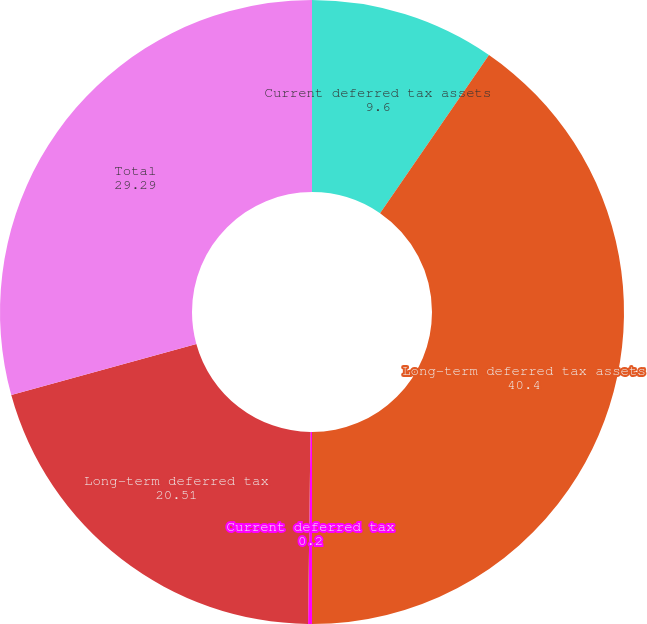Convert chart to OTSL. <chart><loc_0><loc_0><loc_500><loc_500><pie_chart><fcel>Current deferred tax assets<fcel>Long-term deferred tax assets<fcel>Current deferred tax<fcel>Long-term deferred tax<fcel>Total<nl><fcel>9.6%<fcel>40.4%<fcel>0.2%<fcel>20.51%<fcel>29.29%<nl></chart> 